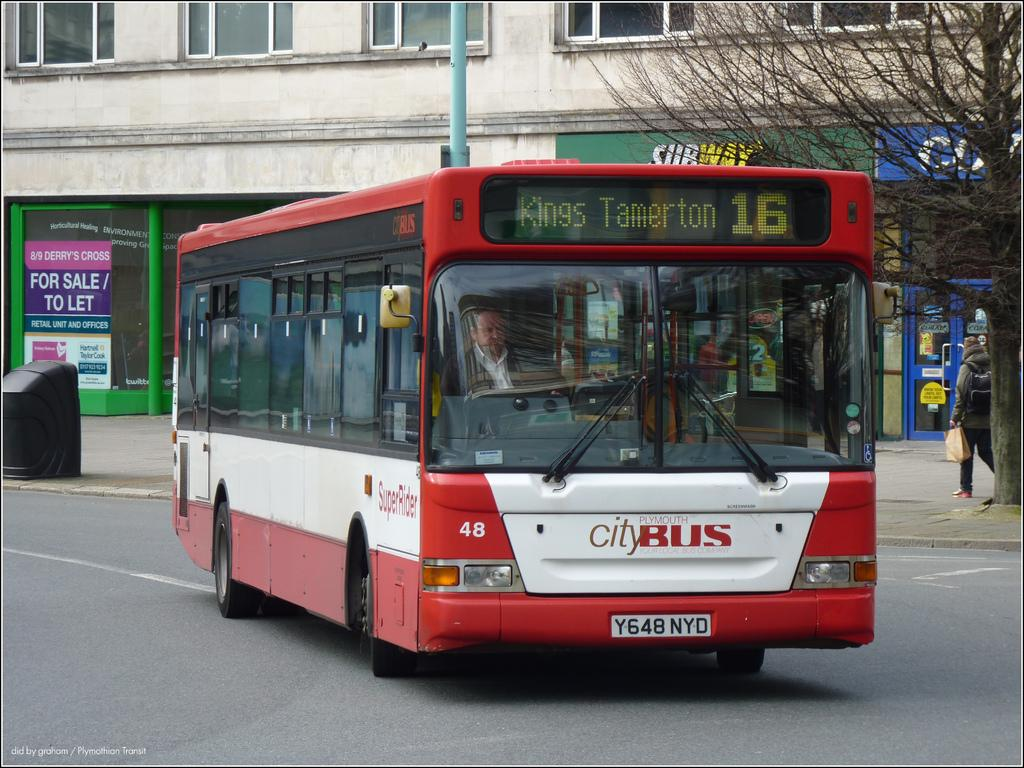<image>
Give a short and clear explanation of the subsequent image. A red and white citybus drives down a street. 